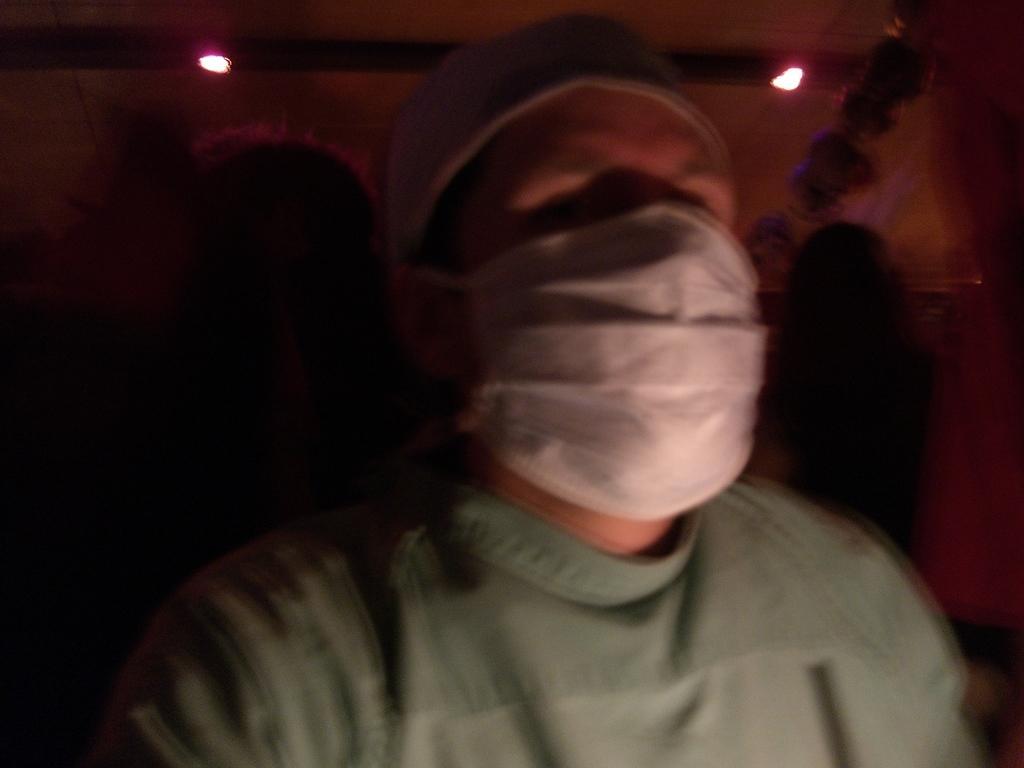How would you summarize this image in a sentence or two? In the center of the image there is a person wearing a white color cap and a mask. The background of the image there is not clear. 